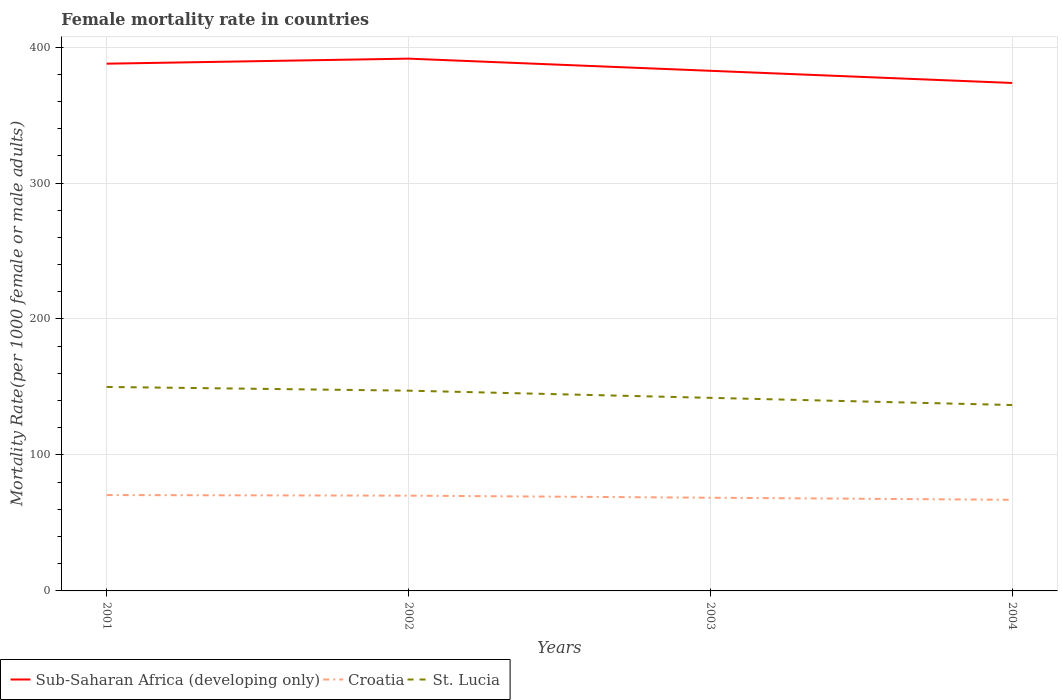Does the line corresponding to St. Lucia intersect with the line corresponding to Croatia?
Give a very brief answer. No. Is the number of lines equal to the number of legend labels?
Ensure brevity in your answer.  Yes. Across all years, what is the maximum female mortality rate in Croatia?
Your response must be concise. 67.02. What is the total female mortality rate in St. Lucia in the graph?
Your answer should be compact. 5.28. What is the difference between the highest and the second highest female mortality rate in Sub-Saharan Africa (developing only)?
Provide a succinct answer. 17.9. What is the difference between the highest and the lowest female mortality rate in Sub-Saharan Africa (developing only)?
Offer a very short reply. 2. Is the female mortality rate in Sub-Saharan Africa (developing only) strictly greater than the female mortality rate in St. Lucia over the years?
Your response must be concise. No. How many years are there in the graph?
Provide a succinct answer. 4. Are the values on the major ticks of Y-axis written in scientific E-notation?
Provide a succinct answer. No. Does the graph contain grids?
Your answer should be compact. Yes. How many legend labels are there?
Your answer should be compact. 3. How are the legend labels stacked?
Provide a short and direct response. Horizontal. What is the title of the graph?
Your response must be concise. Female mortality rate in countries. What is the label or title of the Y-axis?
Your answer should be very brief. Mortality Rate(per 1000 female or male adults). What is the Mortality Rate(per 1000 female or male adults) of Sub-Saharan Africa (developing only) in 2001?
Your response must be concise. 387.78. What is the Mortality Rate(per 1000 female or male adults) in Croatia in 2001?
Your answer should be very brief. 70.51. What is the Mortality Rate(per 1000 female or male adults) of St. Lucia in 2001?
Offer a very short reply. 150.02. What is the Mortality Rate(per 1000 female or male adults) in Sub-Saharan Africa (developing only) in 2002?
Give a very brief answer. 391.5. What is the Mortality Rate(per 1000 female or male adults) in Croatia in 2002?
Offer a terse response. 70.07. What is the Mortality Rate(per 1000 female or male adults) of St. Lucia in 2002?
Provide a short and direct response. 147.29. What is the Mortality Rate(per 1000 female or male adults) of Sub-Saharan Africa (developing only) in 2003?
Make the answer very short. 382.55. What is the Mortality Rate(per 1000 female or male adults) of Croatia in 2003?
Provide a short and direct response. 68.55. What is the Mortality Rate(per 1000 female or male adults) in St. Lucia in 2003?
Keep it short and to the point. 142.01. What is the Mortality Rate(per 1000 female or male adults) in Sub-Saharan Africa (developing only) in 2004?
Your answer should be compact. 373.6. What is the Mortality Rate(per 1000 female or male adults) of Croatia in 2004?
Your answer should be compact. 67.02. What is the Mortality Rate(per 1000 female or male adults) of St. Lucia in 2004?
Provide a succinct answer. 136.73. Across all years, what is the maximum Mortality Rate(per 1000 female or male adults) in Sub-Saharan Africa (developing only)?
Your answer should be very brief. 391.5. Across all years, what is the maximum Mortality Rate(per 1000 female or male adults) in Croatia?
Keep it short and to the point. 70.51. Across all years, what is the maximum Mortality Rate(per 1000 female or male adults) of St. Lucia?
Offer a terse response. 150.02. Across all years, what is the minimum Mortality Rate(per 1000 female or male adults) of Sub-Saharan Africa (developing only)?
Make the answer very short. 373.6. Across all years, what is the minimum Mortality Rate(per 1000 female or male adults) of Croatia?
Your answer should be very brief. 67.02. Across all years, what is the minimum Mortality Rate(per 1000 female or male adults) in St. Lucia?
Ensure brevity in your answer.  136.73. What is the total Mortality Rate(per 1000 female or male adults) in Sub-Saharan Africa (developing only) in the graph?
Ensure brevity in your answer.  1535.44. What is the total Mortality Rate(per 1000 female or male adults) in Croatia in the graph?
Provide a succinct answer. 276.15. What is the total Mortality Rate(per 1000 female or male adults) of St. Lucia in the graph?
Provide a succinct answer. 576.05. What is the difference between the Mortality Rate(per 1000 female or male adults) of Sub-Saharan Africa (developing only) in 2001 and that in 2002?
Provide a short and direct response. -3.71. What is the difference between the Mortality Rate(per 1000 female or male adults) in Croatia in 2001 and that in 2002?
Your answer should be compact. 0.44. What is the difference between the Mortality Rate(per 1000 female or male adults) of St. Lucia in 2001 and that in 2002?
Provide a short and direct response. 2.73. What is the difference between the Mortality Rate(per 1000 female or male adults) of Sub-Saharan Africa (developing only) in 2001 and that in 2003?
Ensure brevity in your answer.  5.23. What is the difference between the Mortality Rate(per 1000 female or male adults) of Croatia in 2001 and that in 2003?
Make the answer very short. 1.96. What is the difference between the Mortality Rate(per 1000 female or male adults) in St. Lucia in 2001 and that in 2003?
Give a very brief answer. 8.01. What is the difference between the Mortality Rate(per 1000 female or male adults) in Sub-Saharan Africa (developing only) in 2001 and that in 2004?
Provide a short and direct response. 14.18. What is the difference between the Mortality Rate(per 1000 female or male adults) in Croatia in 2001 and that in 2004?
Make the answer very short. 3.49. What is the difference between the Mortality Rate(per 1000 female or male adults) of St. Lucia in 2001 and that in 2004?
Make the answer very short. 13.3. What is the difference between the Mortality Rate(per 1000 female or male adults) of Sub-Saharan Africa (developing only) in 2002 and that in 2003?
Make the answer very short. 8.94. What is the difference between the Mortality Rate(per 1000 female or male adults) in Croatia in 2002 and that in 2003?
Offer a very short reply. 1.52. What is the difference between the Mortality Rate(per 1000 female or male adults) in St. Lucia in 2002 and that in 2003?
Your response must be concise. 5.28. What is the difference between the Mortality Rate(per 1000 female or male adults) of Sub-Saharan Africa (developing only) in 2002 and that in 2004?
Your answer should be compact. 17.9. What is the difference between the Mortality Rate(per 1000 female or male adults) in Croatia in 2002 and that in 2004?
Provide a succinct answer. 3.05. What is the difference between the Mortality Rate(per 1000 female or male adults) of St. Lucia in 2002 and that in 2004?
Make the answer very short. 10.57. What is the difference between the Mortality Rate(per 1000 female or male adults) of Sub-Saharan Africa (developing only) in 2003 and that in 2004?
Your response must be concise. 8.95. What is the difference between the Mortality Rate(per 1000 female or male adults) in Croatia in 2003 and that in 2004?
Ensure brevity in your answer.  1.52. What is the difference between the Mortality Rate(per 1000 female or male adults) in St. Lucia in 2003 and that in 2004?
Offer a very short reply. 5.28. What is the difference between the Mortality Rate(per 1000 female or male adults) in Sub-Saharan Africa (developing only) in 2001 and the Mortality Rate(per 1000 female or male adults) in Croatia in 2002?
Ensure brevity in your answer.  317.71. What is the difference between the Mortality Rate(per 1000 female or male adults) of Sub-Saharan Africa (developing only) in 2001 and the Mortality Rate(per 1000 female or male adults) of St. Lucia in 2002?
Keep it short and to the point. 240.49. What is the difference between the Mortality Rate(per 1000 female or male adults) in Croatia in 2001 and the Mortality Rate(per 1000 female or male adults) in St. Lucia in 2002?
Keep it short and to the point. -76.78. What is the difference between the Mortality Rate(per 1000 female or male adults) in Sub-Saharan Africa (developing only) in 2001 and the Mortality Rate(per 1000 female or male adults) in Croatia in 2003?
Offer a terse response. 319.24. What is the difference between the Mortality Rate(per 1000 female or male adults) in Sub-Saharan Africa (developing only) in 2001 and the Mortality Rate(per 1000 female or male adults) in St. Lucia in 2003?
Provide a succinct answer. 245.77. What is the difference between the Mortality Rate(per 1000 female or male adults) of Croatia in 2001 and the Mortality Rate(per 1000 female or male adults) of St. Lucia in 2003?
Provide a short and direct response. -71.5. What is the difference between the Mortality Rate(per 1000 female or male adults) in Sub-Saharan Africa (developing only) in 2001 and the Mortality Rate(per 1000 female or male adults) in Croatia in 2004?
Offer a very short reply. 320.76. What is the difference between the Mortality Rate(per 1000 female or male adults) of Sub-Saharan Africa (developing only) in 2001 and the Mortality Rate(per 1000 female or male adults) of St. Lucia in 2004?
Ensure brevity in your answer.  251.06. What is the difference between the Mortality Rate(per 1000 female or male adults) in Croatia in 2001 and the Mortality Rate(per 1000 female or male adults) in St. Lucia in 2004?
Make the answer very short. -66.22. What is the difference between the Mortality Rate(per 1000 female or male adults) in Sub-Saharan Africa (developing only) in 2002 and the Mortality Rate(per 1000 female or male adults) in Croatia in 2003?
Provide a succinct answer. 322.95. What is the difference between the Mortality Rate(per 1000 female or male adults) in Sub-Saharan Africa (developing only) in 2002 and the Mortality Rate(per 1000 female or male adults) in St. Lucia in 2003?
Your response must be concise. 249.49. What is the difference between the Mortality Rate(per 1000 female or male adults) in Croatia in 2002 and the Mortality Rate(per 1000 female or male adults) in St. Lucia in 2003?
Make the answer very short. -71.94. What is the difference between the Mortality Rate(per 1000 female or male adults) of Sub-Saharan Africa (developing only) in 2002 and the Mortality Rate(per 1000 female or male adults) of Croatia in 2004?
Provide a succinct answer. 324.47. What is the difference between the Mortality Rate(per 1000 female or male adults) of Sub-Saharan Africa (developing only) in 2002 and the Mortality Rate(per 1000 female or male adults) of St. Lucia in 2004?
Offer a very short reply. 254.77. What is the difference between the Mortality Rate(per 1000 female or male adults) in Croatia in 2002 and the Mortality Rate(per 1000 female or male adults) in St. Lucia in 2004?
Provide a short and direct response. -66.66. What is the difference between the Mortality Rate(per 1000 female or male adults) of Sub-Saharan Africa (developing only) in 2003 and the Mortality Rate(per 1000 female or male adults) of Croatia in 2004?
Ensure brevity in your answer.  315.53. What is the difference between the Mortality Rate(per 1000 female or male adults) in Sub-Saharan Africa (developing only) in 2003 and the Mortality Rate(per 1000 female or male adults) in St. Lucia in 2004?
Give a very brief answer. 245.83. What is the difference between the Mortality Rate(per 1000 female or male adults) of Croatia in 2003 and the Mortality Rate(per 1000 female or male adults) of St. Lucia in 2004?
Ensure brevity in your answer.  -68.18. What is the average Mortality Rate(per 1000 female or male adults) in Sub-Saharan Africa (developing only) per year?
Your answer should be compact. 383.86. What is the average Mortality Rate(per 1000 female or male adults) of Croatia per year?
Ensure brevity in your answer.  69.04. What is the average Mortality Rate(per 1000 female or male adults) in St. Lucia per year?
Provide a succinct answer. 144.01. In the year 2001, what is the difference between the Mortality Rate(per 1000 female or male adults) in Sub-Saharan Africa (developing only) and Mortality Rate(per 1000 female or male adults) in Croatia?
Provide a short and direct response. 317.27. In the year 2001, what is the difference between the Mortality Rate(per 1000 female or male adults) of Sub-Saharan Africa (developing only) and Mortality Rate(per 1000 female or male adults) of St. Lucia?
Your answer should be compact. 237.76. In the year 2001, what is the difference between the Mortality Rate(per 1000 female or male adults) in Croatia and Mortality Rate(per 1000 female or male adults) in St. Lucia?
Provide a short and direct response. -79.51. In the year 2002, what is the difference between the Mortality Rate(per 1000 female or male adults) in Sub-Saharan Africa (developing only) and Mortality Rate(per 1000 female or male adults) in Croatia?
Ensure brevity in your answer.  321.43. In the year 2002, what is the difference between the Mortality Rate(per 1000 female or male adults) of Sub-Saharan Africa (developing only) and Mortality Rate(per 1000 female or male adults) of St. Lucia?
Offer a very short reply. 244.2. In the year 2002, what is the difference between the Mortality Rate(per 1000 female or male adults) of Croatia and Mortality Rate(per 1000 female or male adults) of St. Lucia?
Offer a terse response. -77.22. In the year 2003, what is the difference between the Mortality Rate(per 1000 female or male adults) of Sub-Saharan Africa (developing only) and Mortality Rate(per 1000 female or male adults) of Croatia?
Offer a terse response. 314.01. In the year 2003, what is the difference between the Mortality Rate(per 1000 female or male adults) of Sub-Saharan Africa (developing only) and Mortality Rate(per 1000 female or male adults) of St. Lucia?
Keep it short and to the point. 240.54. In the year 2003, what is the difference between the Mortality Rate(per 1000 female or male adults) in Croatia and Mortality Rate(per 1000 female or male adults) in St. Lucia?
Ensure brevity in your answer.  -73.46. In the year 2004, what is the difference between the Mortality Rate(per 1000 female or male adults) in Sub-Saharan Africa (developing only) and Mortality Rate(per 1000 female or male adults) in Croatia?
Your answer should be compact. 306.58. In the year 2004, what is the difference between the Mortality Rate(per 1000 female or male adults) in Sub-Saharan Africa (developing only) and Mortality Rate(per 1000 female or male adults) in St. Lucia?
Your answer should be compact. 236.87. In the year 2004, what is the difference between the Mortality Rate(per 1000 female or male adults) in Croatia and Mortality Rate(per 1000 female or male adults) in St. Lucia?
Give a very brief answer. -69.7. What is the ratio of the Mortality Rate(per 1000 female or male adults) in St. Lucia in 2001 to that in 2002?
Make the answer very short. 1.02. What is the ratio of the Mortality Rate(per 1000 female or male adults) of Sub-Saharan Africa (developing only) in 2001 to that in 2003?
Make the answer very short. 1.01. What is the ratio of the Mortality Rate(per 1000 female or male adults) of Croatia in 2001 to that in 2003?
Provide a short and direct response. 1.03. What is the ratio of the Mortality Rate(per 1000 female or male adults) in St. Lucia in 2001 to that in 2003?
Keep it short and to the point. 1.06. What is the ratio of the Mortality Rate(per 1000 female or male adults) of Sub-Saharan Africa (developing only) in 2001 to that in 2004?
Ensure brevity in your answer.  1.04. What is the ratio of the Mortality Rate(per 1000 female or male adults) of Croatia in 2001 to that in 2004?
Keep it short and to the point. 1.05. What is the ratio of the Mortality Rate(per 1000 female or male adults) in St. Lucia in 2001 to that in 2004?
Give a very brief answer. 1.1. What is the ratio of the Mortality Rate(per 1000 female or male adults) of Sub-Saharan Africa (developing only) in 2002 to that in 2003?
Your answer should be very brief. 1.02. What is the ratio of the Mortality Rate(per 1000 female or male adults) of Croatia in 2002 to that in 2003?
Provide a short and direct response. 1.02. What is the ratio of the Mortality Rate(per 1000 female or male adults) in St. Lucia in 2002 to that in 2003?
Provide a short and direct response. 1.04. What is the ratio of the Mortality Rate(per 1000 female or male adults) of Sub-Saharan Africa (developing only) in 2002 to that in 2004?
Your answer should be very brief. 1.05. What is the ratio of the Mortality Rate(per 1000 female or male adults) of Croatia in 2002 to that in 2004?
Ensure brevity in your answer.  1.05. What is the ratio of the Mortality Rate(per 1000 female or male adults) in St. Lucia in 2002 to that in 2004?
Provide a succinct answer. 1.08. What is the ratio of the Mortality Rate(per 1000 female or male adults) in Croatia in 2003 to that in 2004?
Give a very brief answer. 1.02. What is the ratio of the Mortality Rate(per 1000 female or male adults) of St. Lucia in 2003 to that in 2004?
Your response must be concise. 1.04. What is the difference between the highest and the second highest Mortality Rate(per 1000 female or male adults) of Sub-Saharan Africa (developing only)?
Give a very brief answer. 3.71. What is the difference between the highest and the second highest Mortality Rate(per 1000 female or male adults) of Croatia?
Your answer should be compact. 0.44. What is the difference between the highest and the second highest Mortality Rate(per 1000 female or male adults) of St. Lucia?
Give a very brief answer. 2.73. What is the difference between the highest and the lowest Mortality Rate(per 1000 female or male adults) in Sub-Saharan Africa (developing only)?
Make the answer very short. 17.9. What is the difference between the highest and the lowest Mortality Rate(per 1000 female or male adults) in Croatia?
Offer a terse response. 3.49. What is the difference between the highest and the lowest Mortality Rate(per 1000 female or male adults) in St. Lucia?
Your answer should be compact. 13.3. 